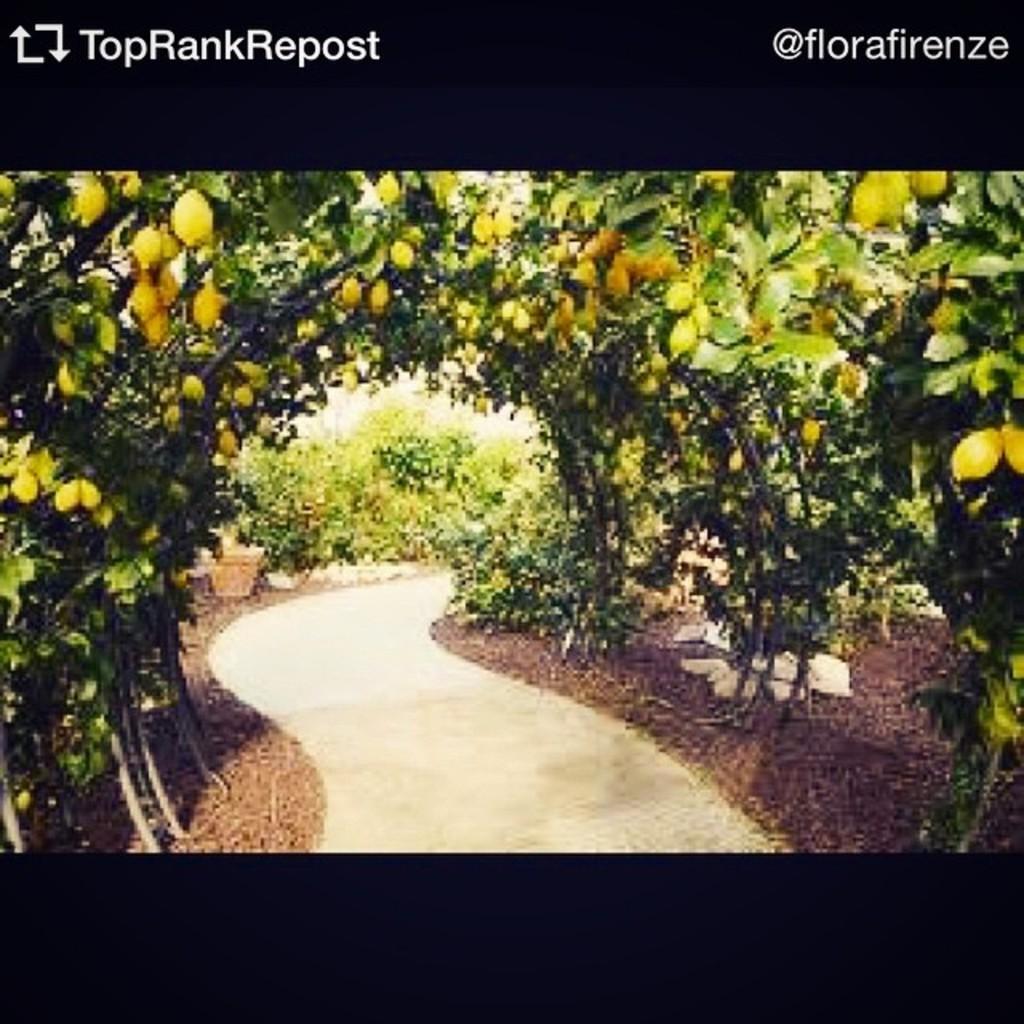How would you summarize this image in a sentence or two? In the picture we can see a photograph with a pathway and on the either sides we can see some plants with fruits which are green in color. 